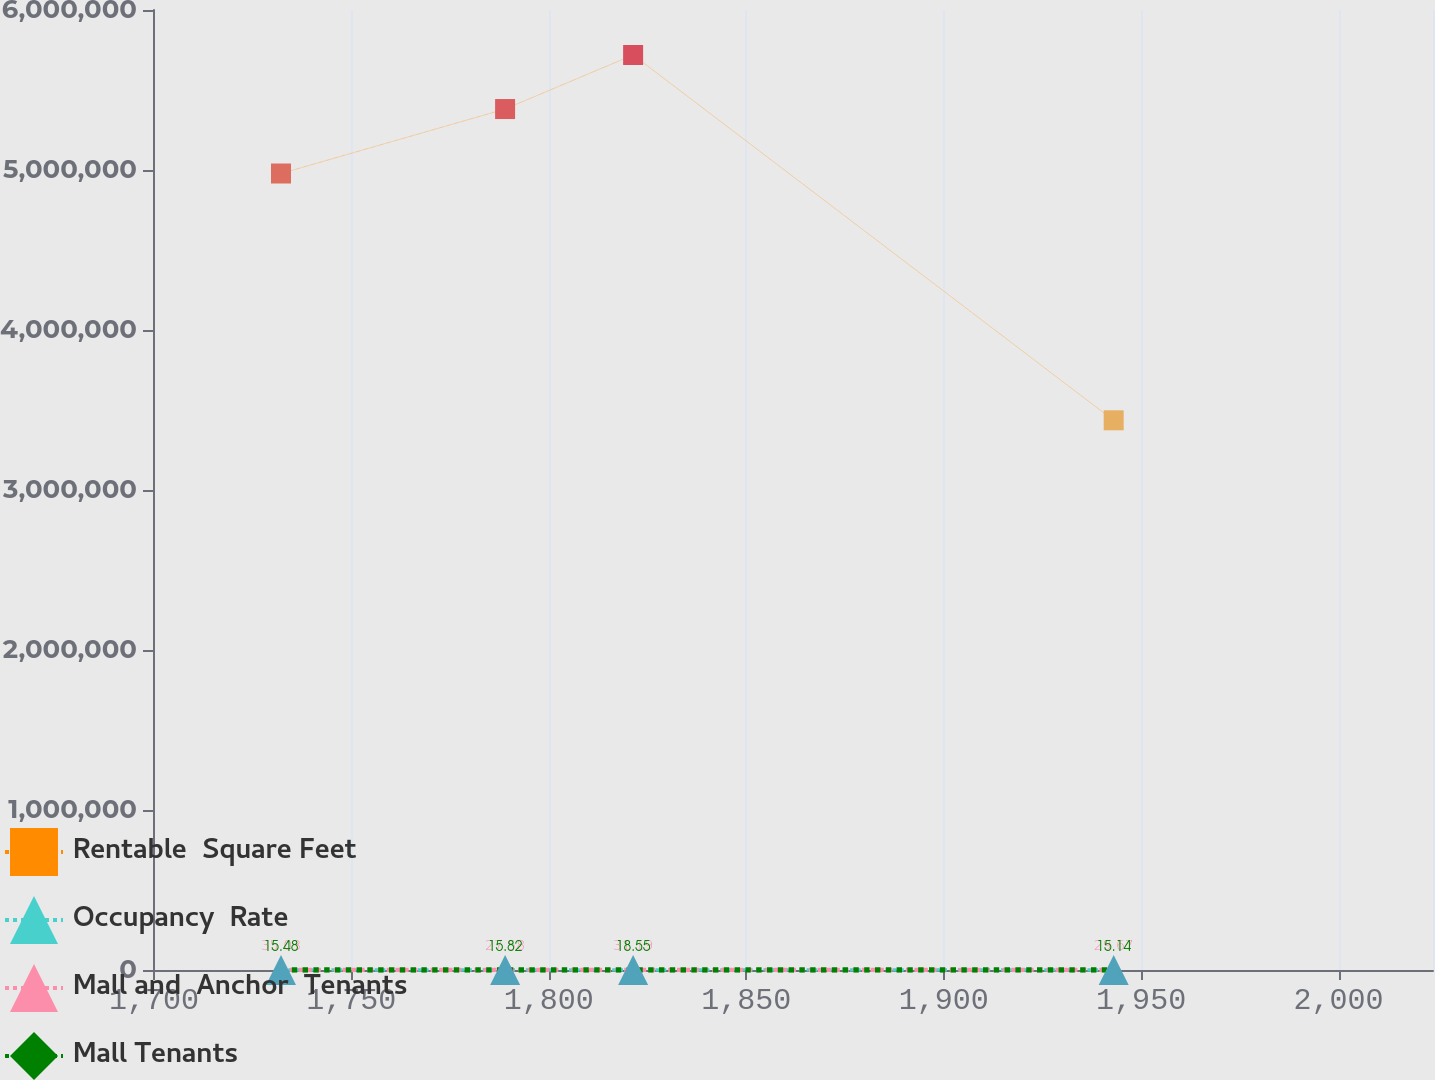<chart> <loc_0><loc_0><loc_500><loc_500><line_chart><ecel><fcel>Rentable  Square Feet<fcel>Occupancy  Rate<fcel>Mall and  Anchor  Tenants<fcel>Mall Tenants<nl><fcel>1732.18<fcel>4.97811e+06<fcel>114.2<fcel>35.03<fcel>15.48<nl><fcel>1788.93<fcel>5.381e+06<fcel>80.53<fcel>27.58<fcel>15.82<nl><fcel>1821.35<fcel>5.71889e+06<fcel>77.03<fcel>31.19<fcel>18.55<nl><fcel>1943.05<fcel>3.43538e+06<fcel>110.7<fcel>29.67<fcel>15.14<nl><fcel>2056.33<fcel>4.05e+06<fcel>90.92<fcel>26.5<fcel>18.15<nl></chart> 